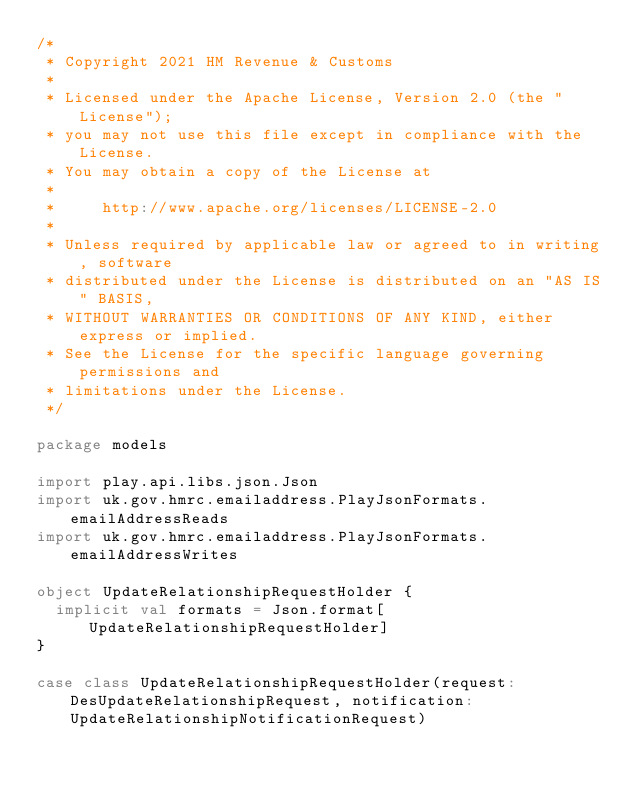Convert code to text. <code><loc_0><loc_0><loc_500><loc_500><_Scala_>/*
 * Copyright 2021 HM Revenue & Customs
 *
 * Licensed under the Apache License, Version 2.0 (the "License");
 * you may not use this file except in compliance with the License.
 * You may obtain a copy of the License at
 *
 *     http://www.apache.org/licenses/LICENSE-2.0
 *
 * Unless required by applicable law or agreed to in writing, software
 * distributed under the License is distributed on an "AS IS" BASIS,
 * WITHOUT WARRANTIES OR CONDITIONS OF ANY KIND, either express or implied.
 * See the License for the specific language governing permissions and
 * limitations under the License.
 */

package models

import play.api.libs.json.Json
import uk.gov.hmrc.emailaddress.PlayJsonFormats.emailAddressReads
import uk.gov.hmrc.emailaddress.PlayJsonFormats.emailAddressWrites

object UpdateRelationshipRequestHolder {
  implicit val formats = Json.format[UpdateRelationshipRequestHolder]
}

case class UpdateRelationshipRequestHolder(request: DesUpdateRelationshipRequest, notification: UpdateRelationshipNotificationRequest)
</code> 